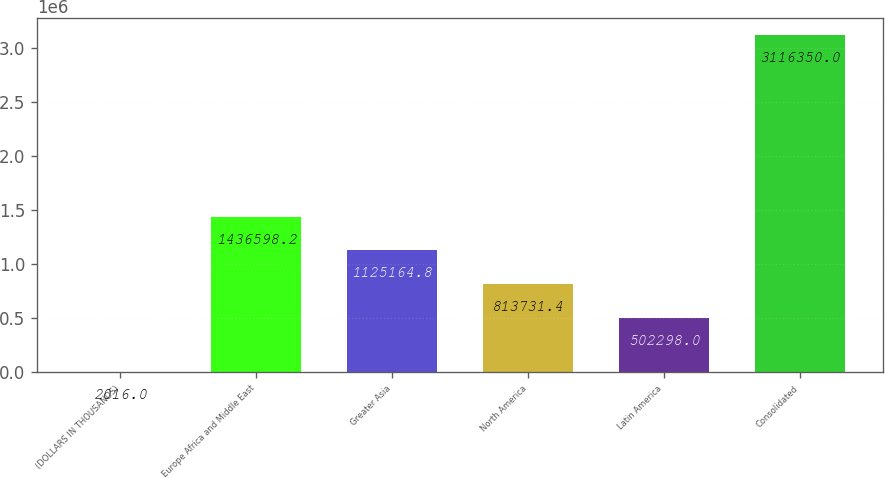Convert chart to OTSL. <chart><loc_0><loc_0><loc_500><loc_500><bar_chart><fcel>(DOLLARS IN THOUSANDS)<fcel>Europe Africa and Middle East<fcel>Greater Asia<fcel>North America<fcel>Latin America<fcel>Consolidated<nl><fcel>2016<fcel>1.4366e+06<fcel>1.12516e+06<fcel>813731<fcel>502298<fcel>3.11635e+06<nl></chart> 